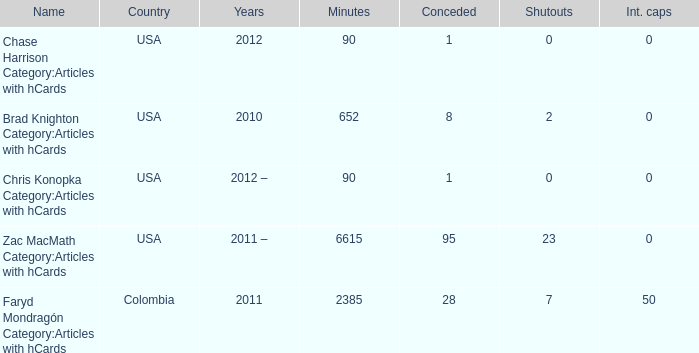When 2010 is the year what is the game? 8.0. 